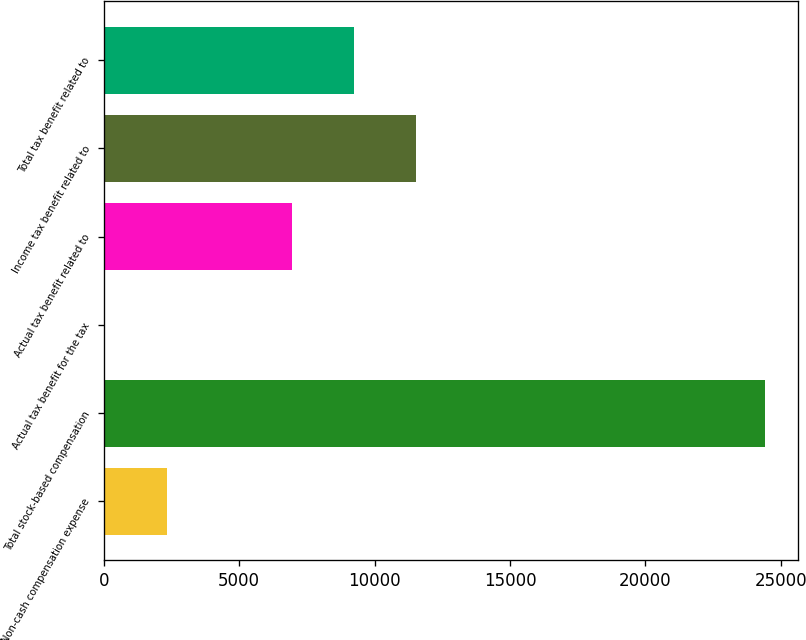Convert chart. <chart><loc_0><loc_0><loc_500><loc_500><bar_chart><fcel>Non-cash compensation expense<fcel>Total stock-based compensation<fcel>Actual tax benefit for the tax<fcel>Actual tax benefit related to<fcel>Income tax benefit related to<fcel>Total tax benefit related to<nl><fcel>2330.9<fcel>24426.9<fcel>29<fcel>6934.7<fcel>11538.5<fcel>9236.6<nl></chart> 